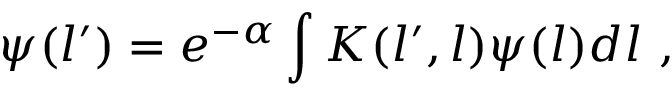Convert formula to latex. <formula><loc_0><loc_0><loc_500><loc_500>\psi ( l ^ { \prime } ) = e ^ { - \alpha } \int K ( l ^ { \prime } , l ) \psi ( l ) d l \ ,</formula> 